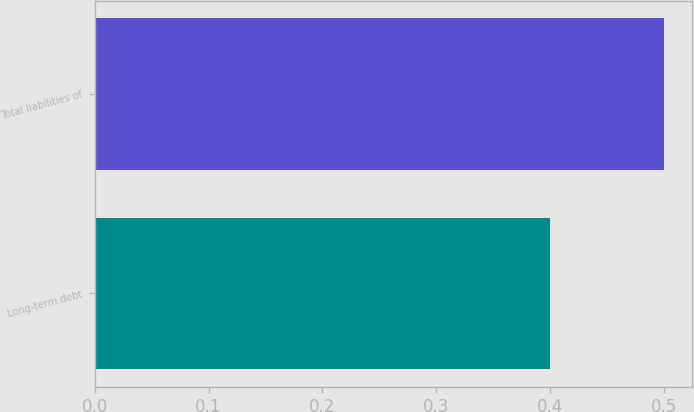Convert chart to OTSL. <chart><loc_0><loc_0><loc_500><loc_500><bar_chart><fcel>Long-term debt<fcel>Total liabilities of<nl><fcel>0.4<fcel>0.5<nl></chart> 